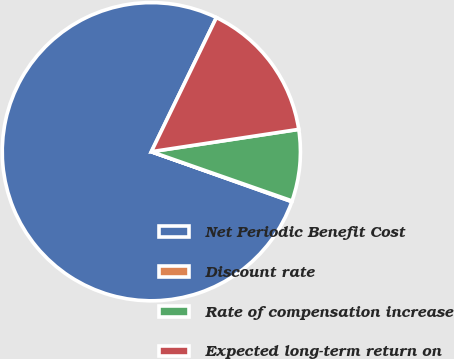Convert chart to OTSL. <chart><loc_0><loc_0><loc_500><loc_500><pie_chart><fcel>Net Periodic Benefit Cost<fcel>Discount rate<fcel>Rate of compensation increase<fcel>Expected long-term return on<nl><fcel>76.76%<fcel>0.08%<fcel>7.75%<fcel>15.42%<nl></chart> 